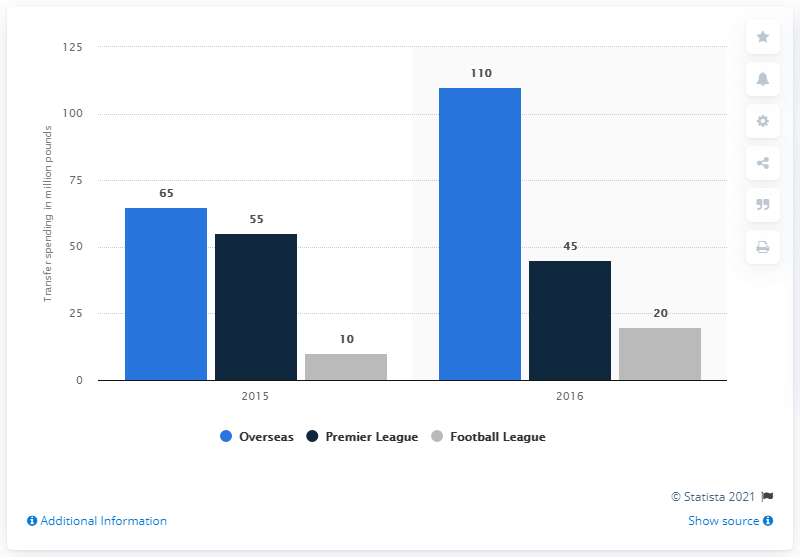Identify some key points in this picture. In January 2015, a transfer fee was paid for players from overseas leagues, and it was 65... 